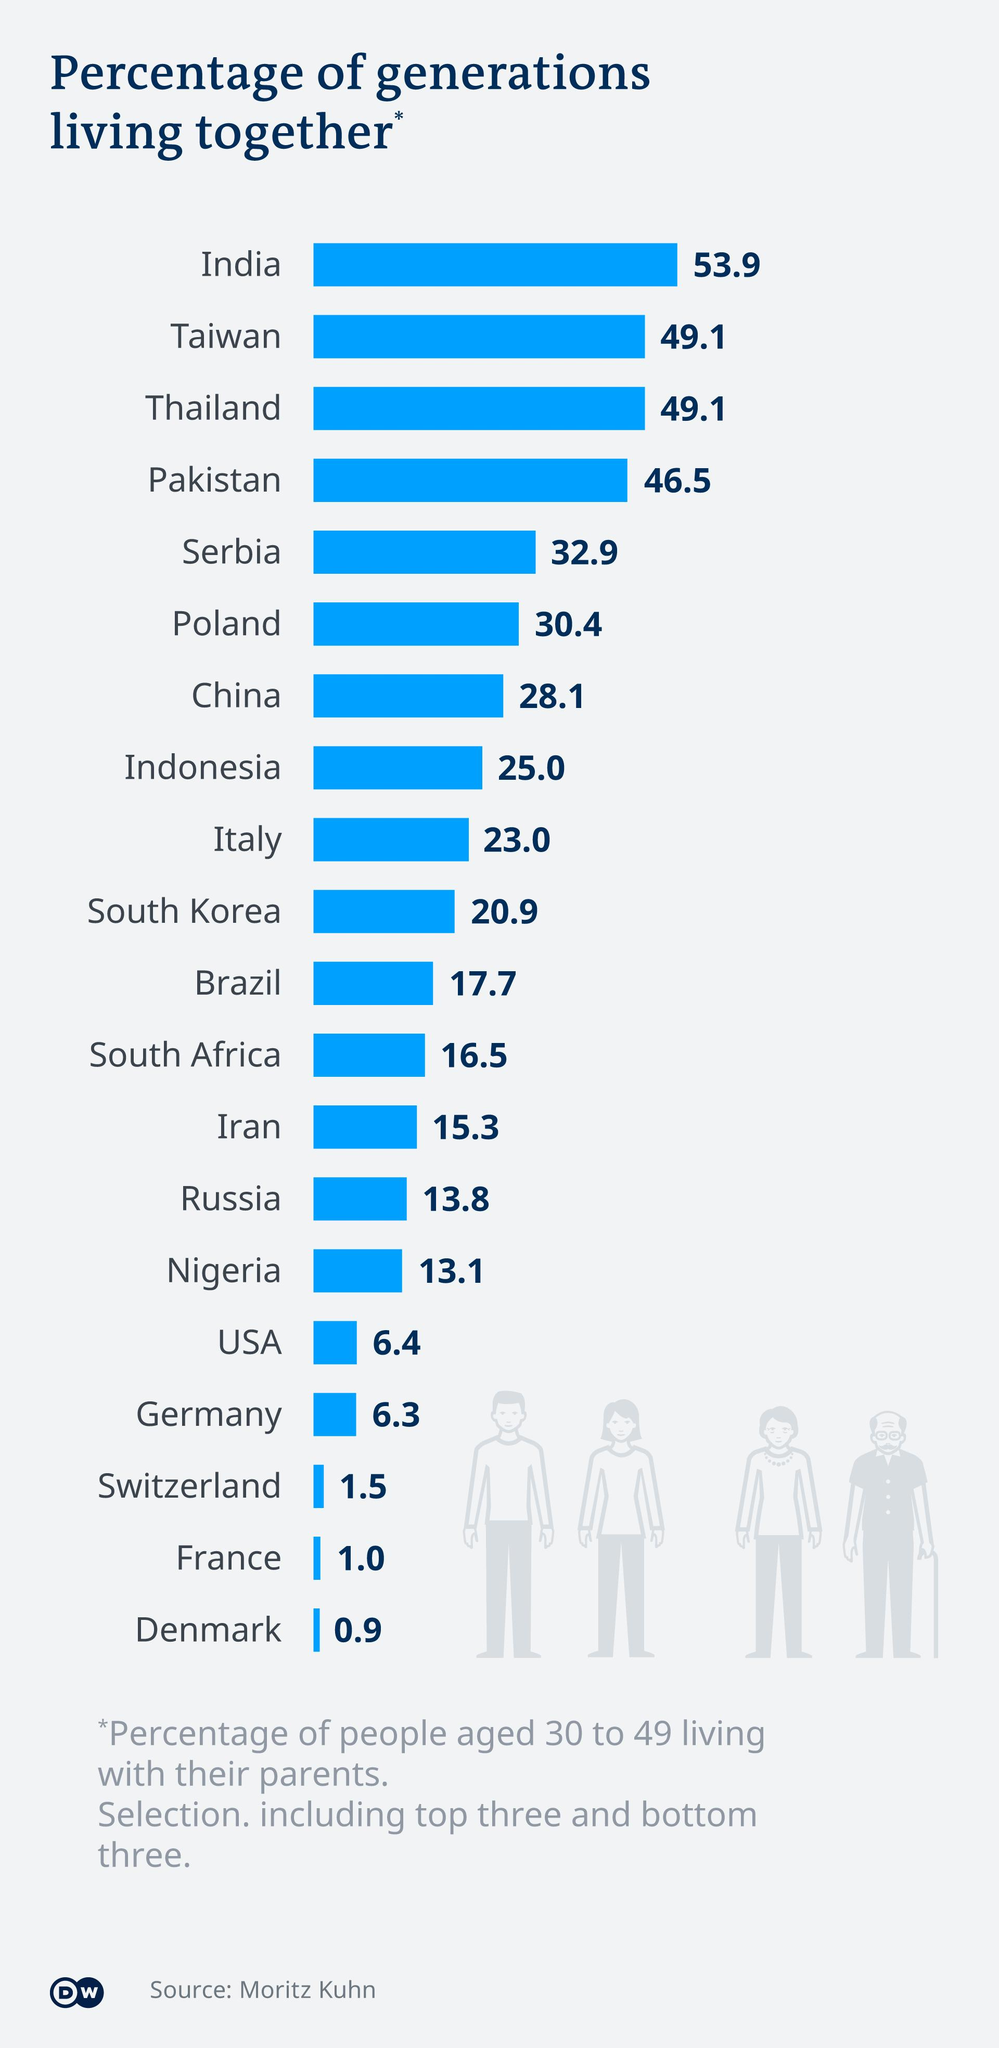Draw attention to some important aspects in this diagram. India is the country where more than half of the generations are living together. According to recent data, several countries are witnessing an increasing trend in the number of generations living together, with Taiwan and Thailand leading the way with 49.1% of their populations living in multi-generational households. The infographic depicts 4 individuals. The survey includes 20 countries. According to the given information, Switzerland, France, and Denmark are countries where less than 2% of generations of people have lived together. 